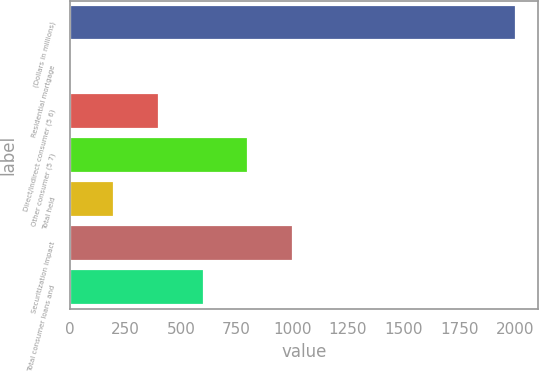<chart> <loc_0><loc_0><loc_500><loc_500><bar_chart><fcel>(Dollars in millions)<fcel>Residential mortgage<fcel>Direct/Indirect consumer (5 6)<fcel>Other consumer (5 7)<fcel>Total held<fcel>Securitization impact<fcel>Total consumer loans and<nl><fcel>2006<fcel>0.02<fcel>401.22<fcel>802.42<fcel>200.62<fcel>1003.02<fcel>601.82<nl></chart> 